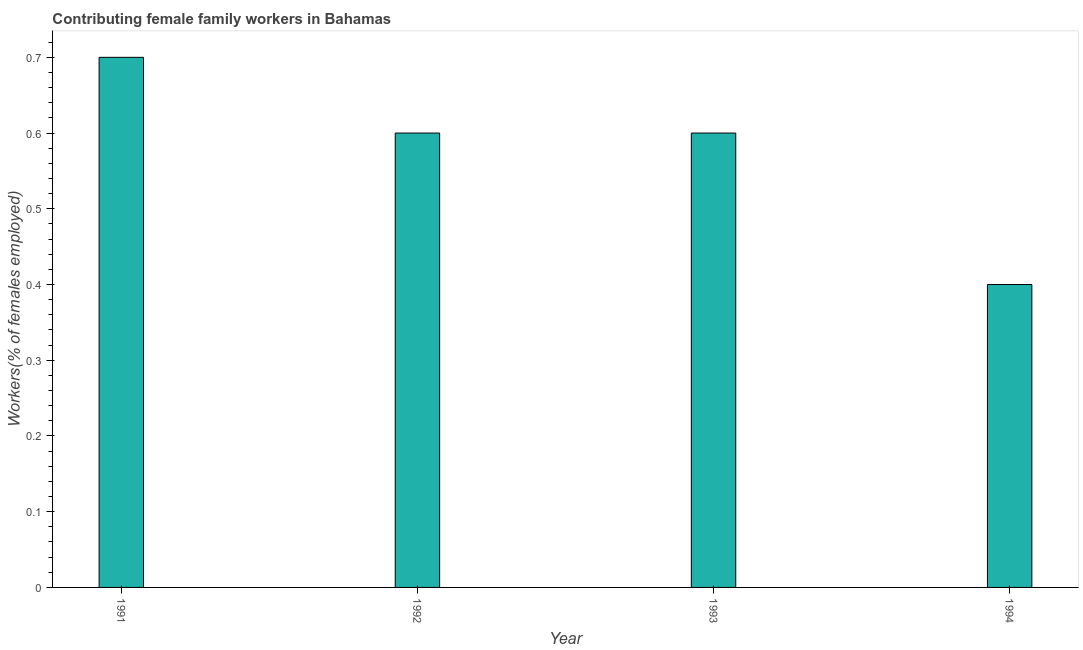Does the graph contain any zero values?
Keep it short and to the point. No. What is the title of the graph?
Offer a very short reply. Contributing female family workers in Bahamas. What is the label or title of the X-axis?
Ensure brevity in your answer.  Year. What is the label or title of the Y-axis?
Keep it short and to the point. Workers(% of females employed). What is the contributing female family workers in 1991?
Offer a very short reply. 0.7. Across all years, what is the maximum contributing female family workers?
Your answer should be compact. 0.7. Across all years, what is the minimum contributing female family workers?
Your response must be concise. 0.4. What is the sum of the contributing female family workers?
Your response must be concise. 2.3. What is the difference between the contributing female family workers in 1992 and 1993?
Provide a succinct answer. 0. What is the average contributing female family workers per year?
Provide a succinct answer. 0.57. What is the median contributing female family workers?
Keep it short and to the point. 0.6. What is the ratio of the contributing female family workers in 1991 to that in 1994?
Provide a short and direct response. 1.75. Is the contributing female family workers in 1992 less than that in 1993?
Keep it short and to the point. No. Is the difference between the contributing female family workers in 1992 and 1993 greater than the difference between any two years?
Your answer should be compact. No. What is the difference between the highest and the second highest contributing female family workers?
Offer a terse response. 0.1. Is the sum of the contributing female family workers in 1991 and 1992 greater than the maximum contributing female family workers across all years?
Your answer should be compact. Yes. What is the difference between the highest and the lowest contributing female family workers?
Your answer should be very brief. 0.3. Are all the bars in the graph horizontal?
Make the answer very short. No. How many years are there in the graph?
Ensure brevity in your answer.  4. What is the Workers(% of females employed) of 1991?
Offer a terse response. 0.7. What is the Workers(% of females employed) in 1992?
Your answer should be very brief. 0.6. What is the Workers(% of females employed) in 1993?
Give a very brief answer. 0.6. What is the Workers(% of females employed) of 1994?
Your response must be concise. 0.4. What is the difference between the Workers(% of females employed) in 1991 and 1994?
Provide a short and direct response. 0.3. What is the difference between the Workers(% of females employed) in 1992 and 1993?
Offer a terse response. 0. What is the difference between the Workers(% of females employed) in 1992 and 1994?
Give a very brief answer. 0.2. What is the ratio of the Workers(% of females employed) in 1991 to that in 1992?
Make the answer very short. 1.17. What is the ratio of the Workers(% of females employed) in 1991 to that in 1993?
Provide a succinct answer. 1.17. What is the ratio of the Workers(% of females employed) in 1991 to that in 1994?
Your response must be concise. 1.75. What is the ratio of the Workers(% of females employed) in 1992 to that in 1993?
Provide a succinct answer. 1. What is the ratio of the Workers(% of females employed) in 1993 to that in 1994?
Provide a short and direct response. 1.5. 